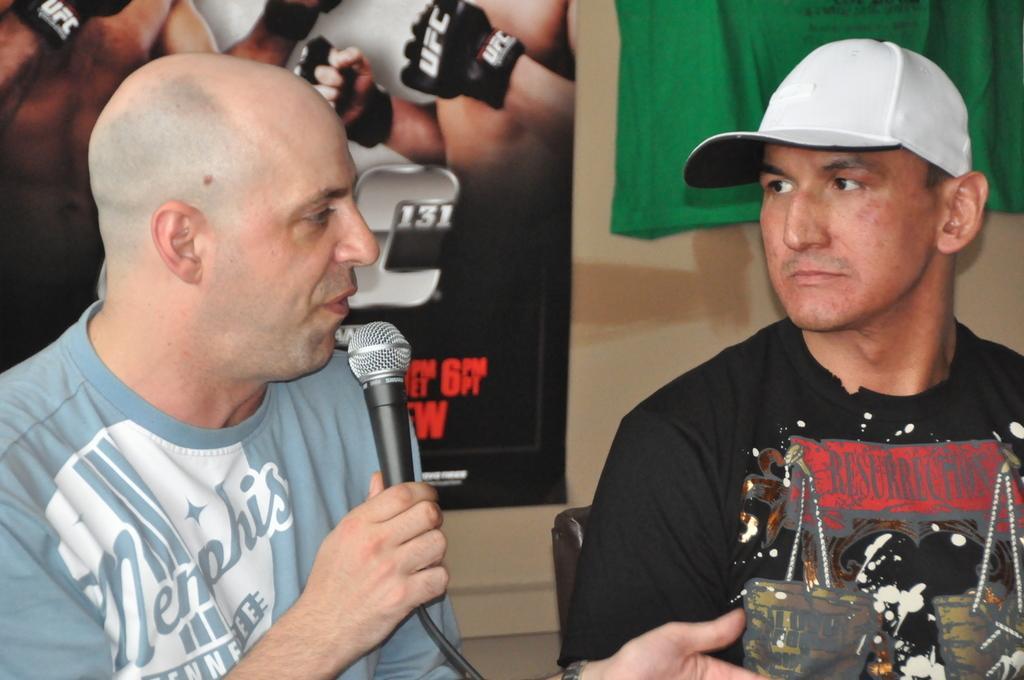Can you describe this image briefly? In this image we can see two persons are sitting on the chair, and holding the micro phone in the hand and speaking, and at back here is the wall. 